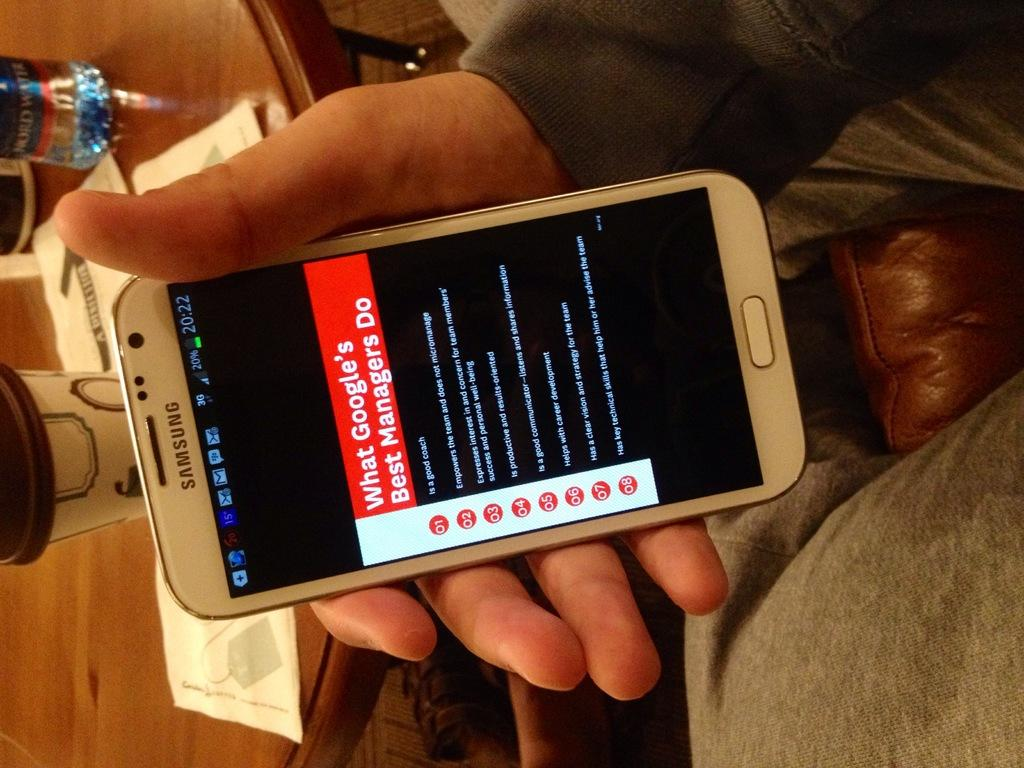<image>
Give a short and clear explanation of the subsequent image. A Samsung cell phone with a message saying "What Google's Best Managers Do" 